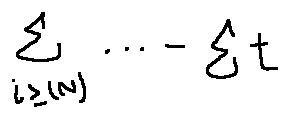Convert formula to latex. <formula><loc_0><loc_0><loc_500><loc_500>\sum \lim i t s _ { i \geq ( N ) } \cdots - \sum t</formula> 